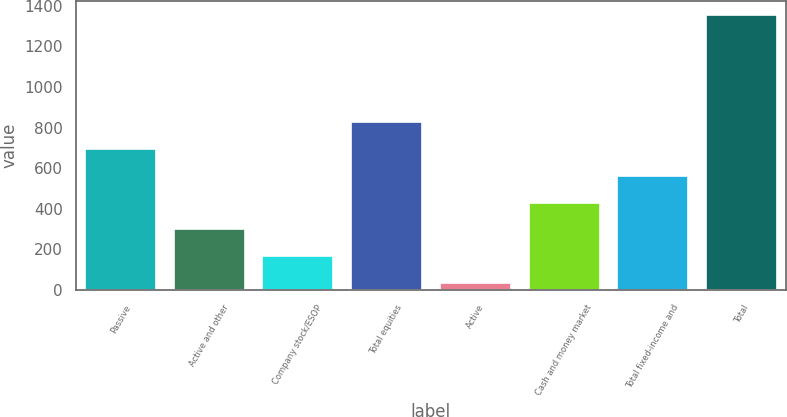<chart> <loc_0><loc_0><loc_500><loc_500><bar_chart><fcel>Passive<fcel>Active and other<fcel>Company stock/ESOP<fcel>Total equities<fcel>Active<fcel>Cash and money market<fcel>Total fixed-income and<fcel>Total<nl><fcel>694.5<fcel>298.8<fcel>166.9<fcel>826.4<fcel>35<fcel>430.7<fcel>562.6<fcel>1354<nl></chart> 